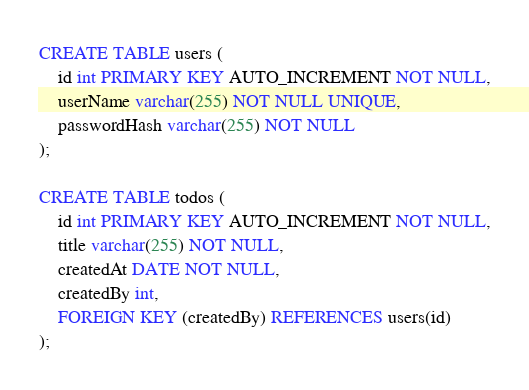<code> <loc_0><loc_0><loc_500><loc_500><_SQL_>CREATE TABLE users (
	id int PRIMARY KEY AUTO_INCREMENT NOT NULL,
    userName varchar(255) NOT NULL UNIQUE,
    passwordHash varchar(255) NOT NULL
);

CREATE TABLE todos (
	id int PRIMARY KEY AUTO_INCREMENT NOT NULL,
    title varchar(255) NOT NULL,
    createdAt DATE NOT NULL,
    createdBy int,
    FOREIGN KEY (createdBy) REFERENCES users(id)
);</code> 